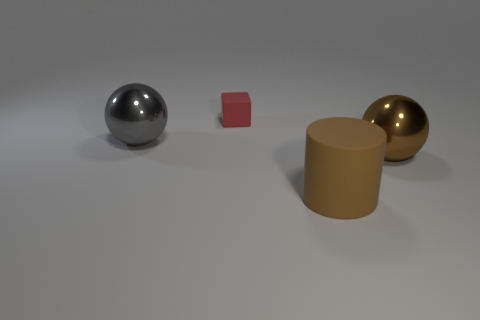Is there a source of light in this image that is causing the shadows? While the light source is not directly visible in the image, the shadows of the objects indicate that there is a lighting source above and to the left of the scene, as evidenced by the direction and the length of the shadows. 